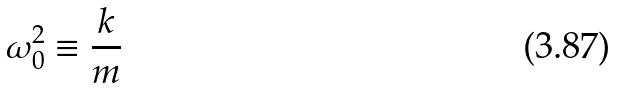<formula> <loc_0><loc_0><loc_500><loc_500>\omega _ { 0 } ^ { 2 } \equiv \frac { k } { m }</formula> 